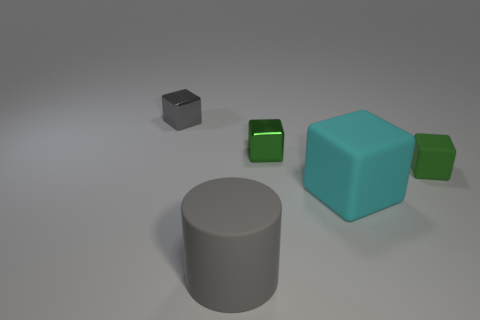Subtract all yellow balls. How many green blocks are left? 2 Subtract all large rubber blocks. How many blocks are left? 3 Subtract all gray blocks. How many blocks are left? 3 Add 2 green metallic cubes. How many objects exist? 7 Subtract all blocks. How many objects are left? 1 Subtract all tiny cyan matte cylinders. Subtract all small metallic objects. How many objects are left? 3 Add 5 green rubber things. How many green rubber things are left? 6 Add 2 small red matte spheres. How many small red matte spheres exist? 2 Subtract 0 blue blocks. How many objects are left? 5 Subtract all yellow blocks. Subtract all yellow cylinders. How many blocks are left? 4 